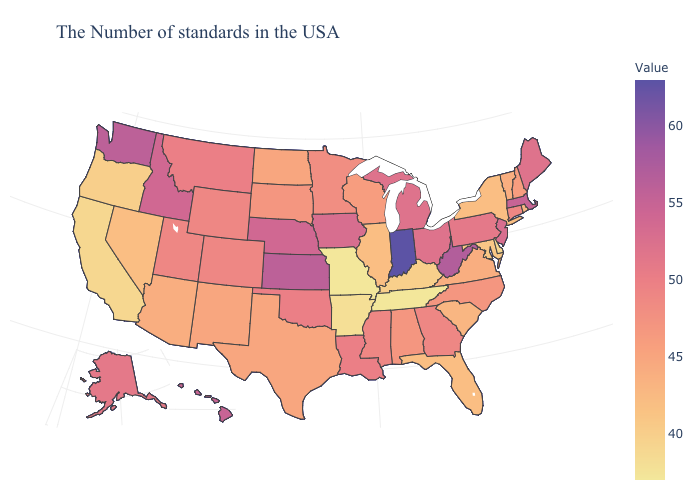Among the states that border West Virginia , which have the highest value?
Keep it brief. Ohio. Does Illinois have a lower value than Mississippi?
Short answer required. Yes. Does Montana have a lower value than Illinois?
Answer briefly. No. Does North Dakota have a lower value than New Jersey?
Answer briefly. Yes. Among the states that border Connecticut , which have the highest value?
Concise answer only. Massachusetts. 